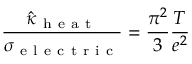<formula> <loc_0><loc_0><loc_500><loc_500>\frac { \hat { \kappa } _ { h e a t } } { \sigma _ { e l e c t r i c } } = \frac { \pi ^ { 2 } } { 3 } \frac { T } { e ^ { 2 } }</formula> 